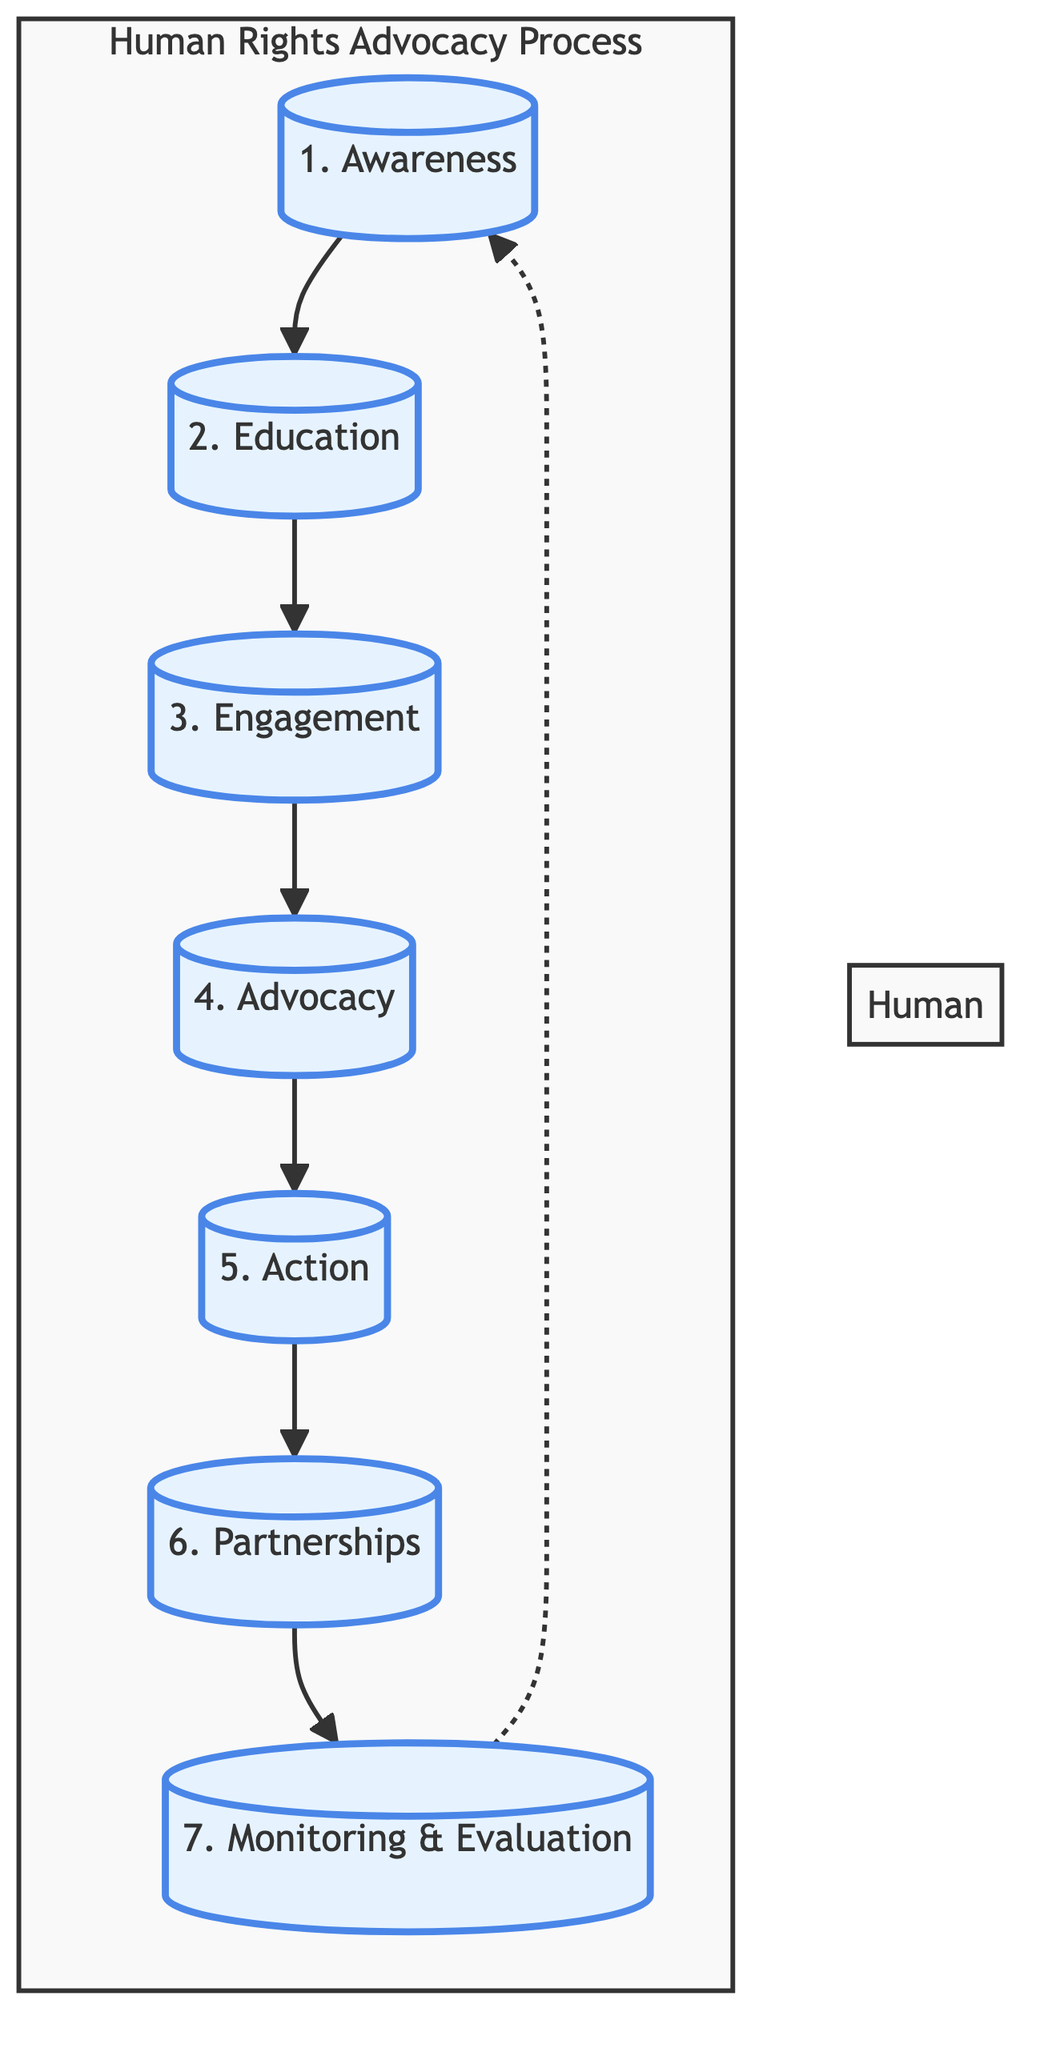What is the first step in the advocacy process? The flowchart indicates that the first step is labeled "Awareness," which is represented by the first node in the diagram.
Answer: Awareness How many steps are in the advocacy process? There are seven steps listed in the flowchart, which can be counted by identifying each distinct node in the diagram.
Answer: 7 Which step comes after "Engagement"? In the flowchart, the step that follows "Engagement" is "Advocacy," as shown by the direct arrow connecting these two nodes.
Answer: Advocacy What step involves lobbying government representatives? The flowchart specifies that "Advocacy" is the step associated with lobbying government representatives and participating in campaigns.
Answer: Advocacy What is the last step in the advocacy process? The flowchart clearly indicates that "Monitoring & Evaluation" is the last step, as it is the final node in the sequence.
Answer: Monitoring & Evaluation Which steps are directly connected to "Action"? The flowchart shows that "Action" is directly connected to two steps: "Advocacy," which precedes it, and "Partnerships," which follows it.
Answer: Advocacy, Partnerships How does the process cycle back? The flowchart illustrates a dotted line from "Monitoring & Evaluation" back to "Awareness," indicating that the process can cycle back to the beginning, allowing for continuous improvement.
Answer: Dotted line from Monitoring & Evaluation to Awareness Which step emphasizes collaboration? According to the diagram, the step labeled "Partnerships" clearly emphasizes collaboration with other organizations, churches, and community groups.
Answer: Partnerships 